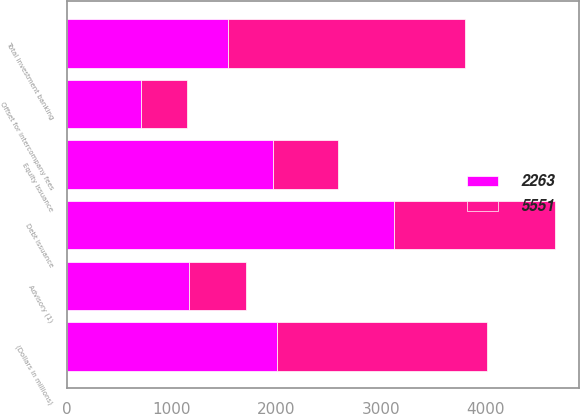<chart> <loc_0><loc_0><loc_500><loc_500><stacked_bar_chart><ecel><fcel>(Dollars in millions)<fcel>Advisory (1)<fcel>Debt issuance<fcel>Equity issuance<fcel>Offset for intercompany fees<fcel>Total investment banking<nl><fcel>2263<fcel>2009<fcel>1167<fcel>3124<fcel>1964<fcel>704<fcel>1539<nl><fcel>5551<fcel>2008<fcel>546<fcel>1539<fcel>624<fcel>446<fcel>2263<nl></chart> 